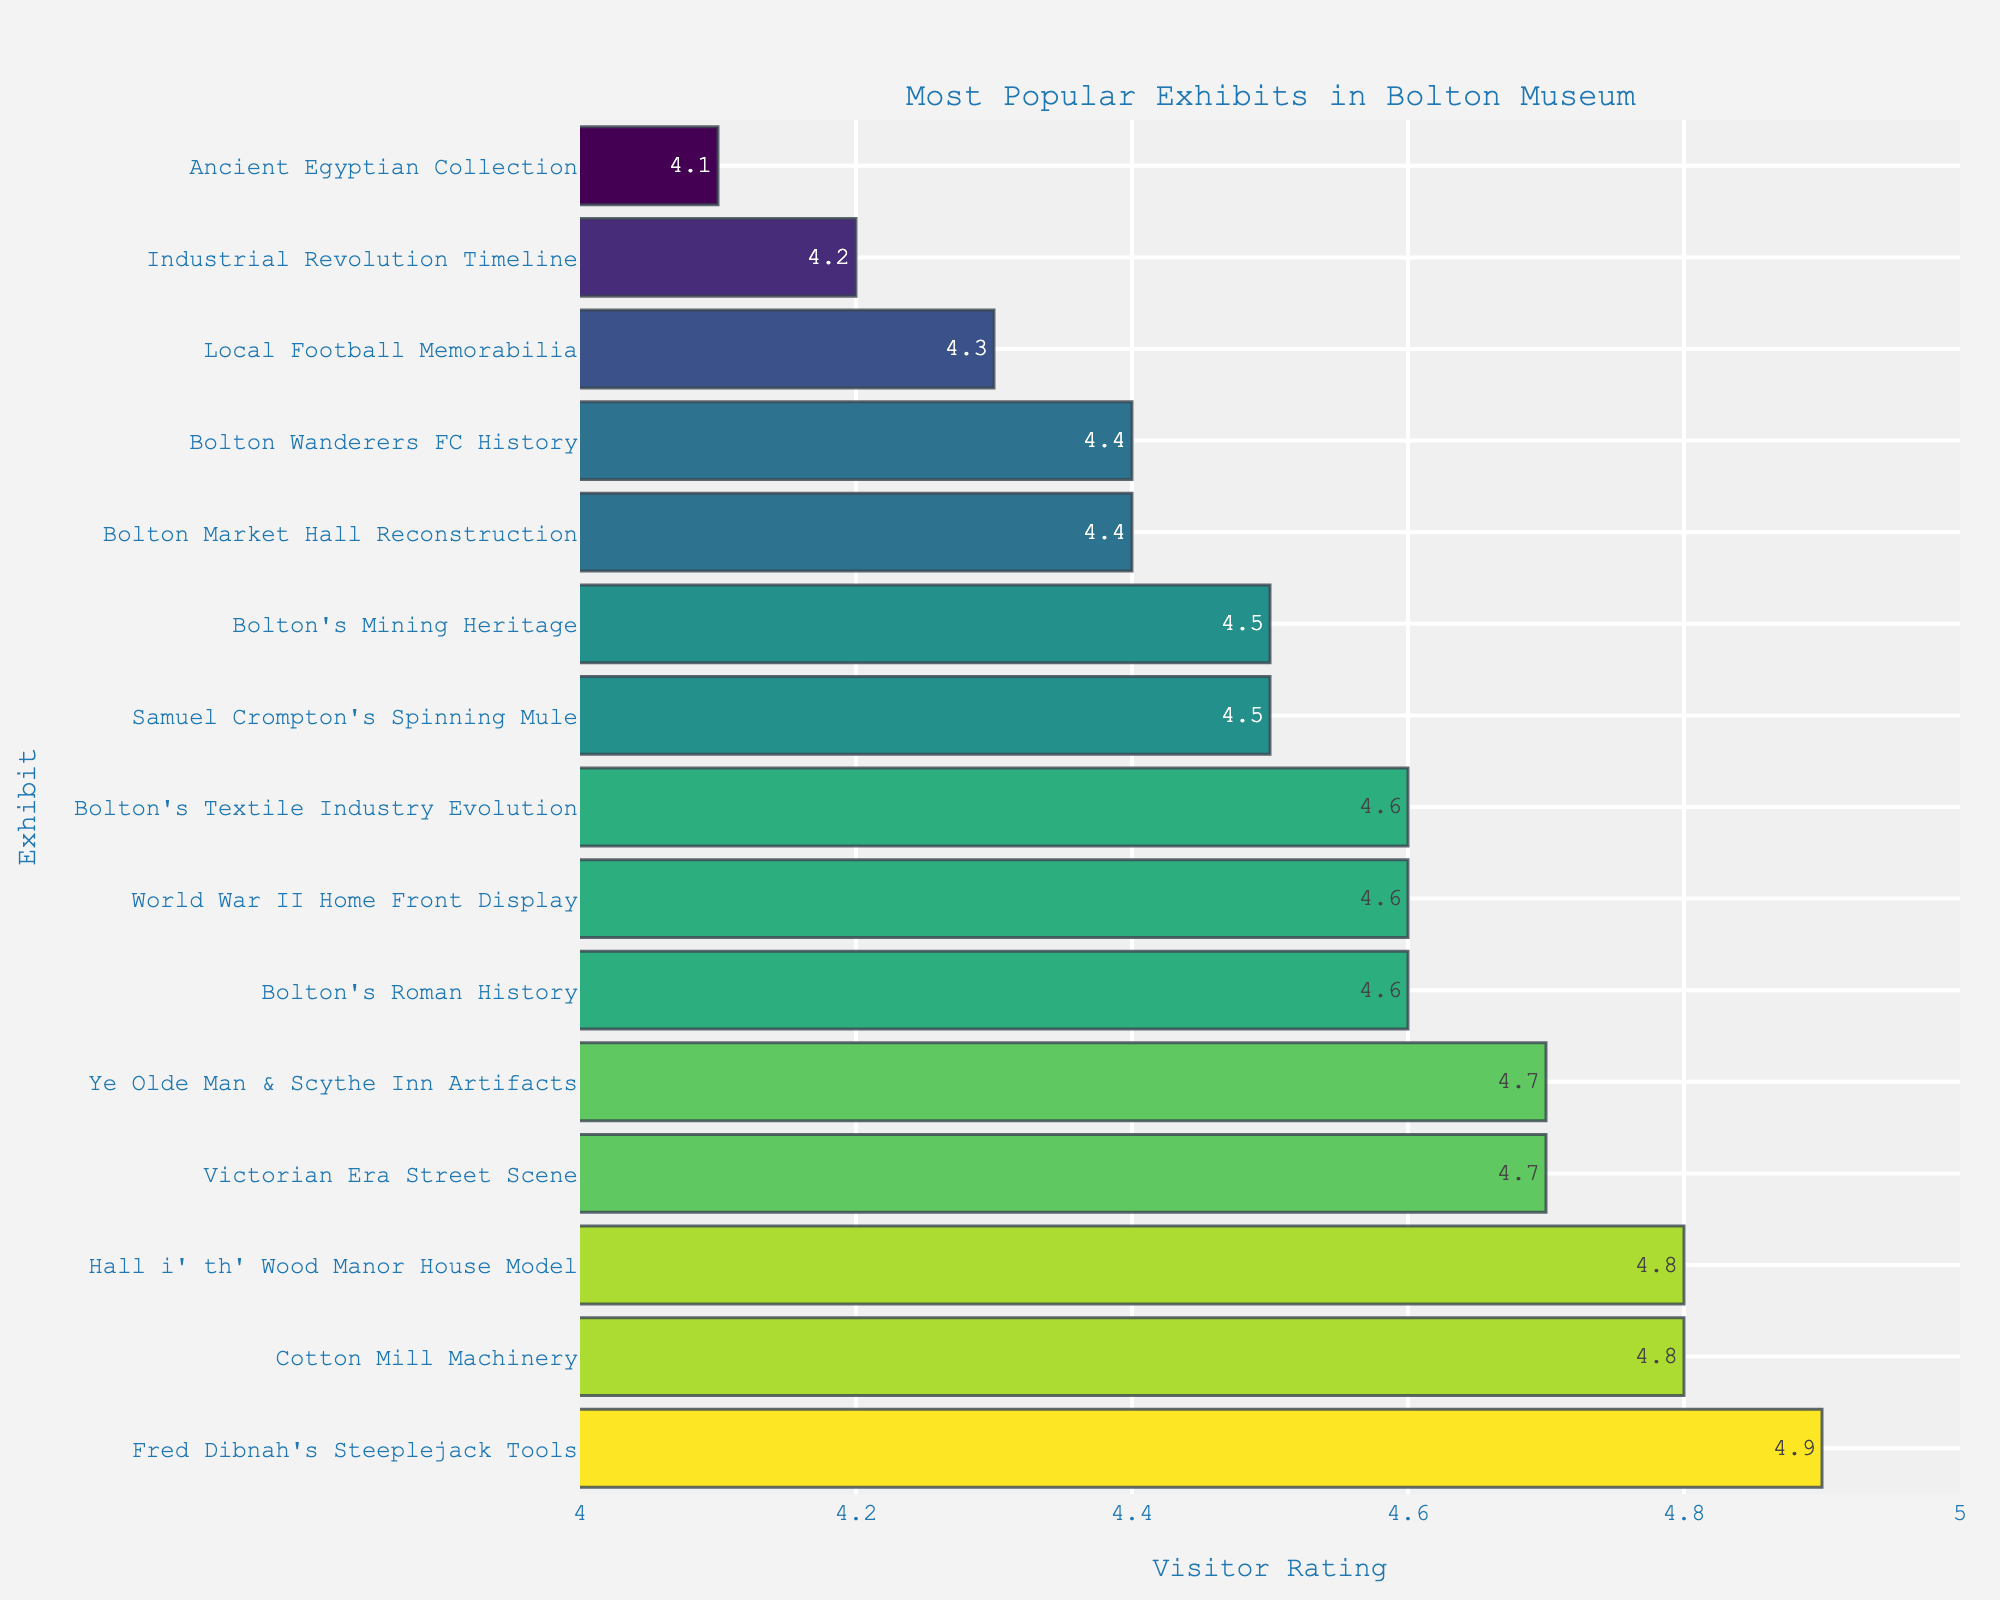Which exhibit received the highest visitor rating? The exhibit with the highest visitor rating has the longest bar in the chart. Fred Dibnah's Steeplejack Tools exhibits the highest rating with a value of 4.9.
Answer: Fred Dibnah's Steeplejack Tools Which exhibit received the lowest visitor rating? The shortest bar in the chart represents the exhibit with the lowest visitor rating. This belongs to the Ancient Egyptian Collection, with a rating of 4.1.
Answer: Ancient Egyptian Collection How many exhibits received a visitor rating of at least 4.7? Look for the bars that extend to at least 4.7 on the x-axis. The exhibits are Cotton Mill Machinery (4.8), Victorian Era Street Scene (4.7), Fred Dibnah's Steeplejack Tools (4.9), Ye Olde Man & Scythe Inn Artifacts (4.7), and Hall i' th' Wood Manor House Model (4.8). There are 5 such exhibits.
Answer: 5 What is the difference in visitor rating between the highest-rated and lowest-rated exhibit? Subtract the visitor rating of the lowest-rated exhibit (Ancient Egyptian Collection, 4.1) from the highest-rated exhibit (Fred Dibnah's Steeplejack Tools, 4.9). 4.9 - 4.1 = 0.8.
Answer: 0.8 Which two exhibits received the same visitor rating of 4.6? Identify the bars that extend to the 4.6 mark on the x-axis. These are Bolton's Roman History, World War II Home Front Display, and Bolton's Textile Industry Evolution.
Answer: Bolton's Roman History, World War II Home Front Display, Bolton's Textile Industry Evolution What is the average visitor rating of the exhibits rated 4.5? The exhibits rated 4.5 are Samuel Crompton's Spinning Mule and Bolton's Mining Heritage. Their sum is 4.5 + 4.5 = 9. Divide by 2, which gives 9 / 2 = 4.5.
Answer: 4.5 What is the total number of exhibits rated between 4.6 and 4.8, inclusive? Identify the exhibits with bars between 4.6 and 4.8 (including 4.6 and 4.8). These are Bolton's Roman History (4.6), Victorian Era Street Scene (4.7), Cotton Mill Machinery (4.8), Ye Olde Man & Scythe Inn Artifacts (4.7), Bolton's Textile Industry Evolution (4.6), and Hall i' th' Wood Manor House Model (4.8). There are 6 such exhibits.
Answer: 6 Which exhibit rated 4.3 by visitors? The bar reaching up to 4.3 represents Local Football Memorabilia.
Answer: Local Football Memorabilia 